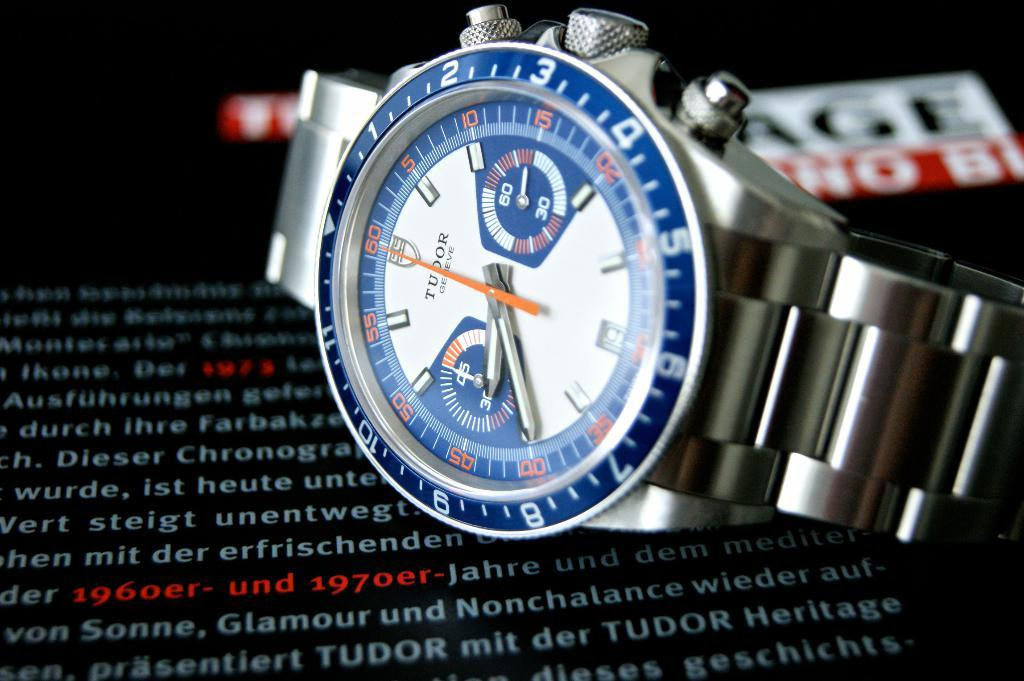<image>
Relay a brief, clear account of the picture shown. A Tudor watch sitting on an advertisement stating it was made between 1960 and 1970. 